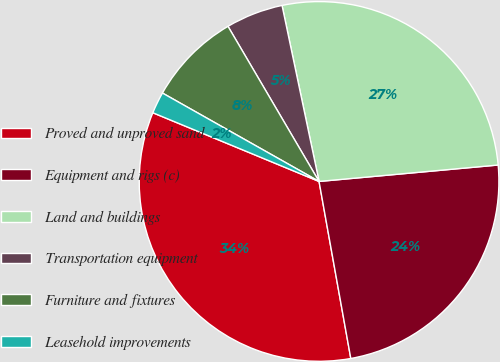Convert chart to OTSL. <chart><loc_0><loc_0><loc_500><loc_500><pie_chart><fcel>Proved and unproved sand<fcel>Equipment and rigs (c)<fcel>Land and buildings<fcel>Transportation equipment<fcel>Furniture and fixtures<fcel>Leasehold improvements<nl><fcel>34.06%<fcel>23.63%<fcel>26.84%<fcel>5.15%<fcel>8.37%<fcel>1.94%<nl></chart> 